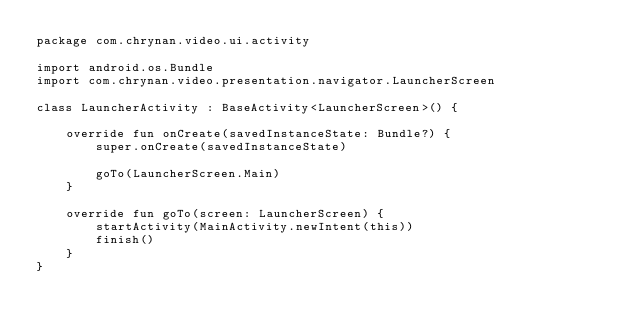Convert code to text. <code><loc_0><loc_0><loc_500><loc_500><_Kotlin_>package com.chrynan.video.ui.activity

import android.os.Bundle
import com.chrynan.video.presentation.navigator.LauncherScreen

class LauncherActivity : BaseActivity<LauncherScreen>() {

    override fun onCreate(savedInstanceState: Bundle?) {
        super.onCreate(savedInstanceState)

        goTo(LauncherScreen.Main)
    }

    override fun goTo(screen: LauncherScreen) {
        startActivity(MainActivity.newIntent(this))
        finish()
    }
}</code> 